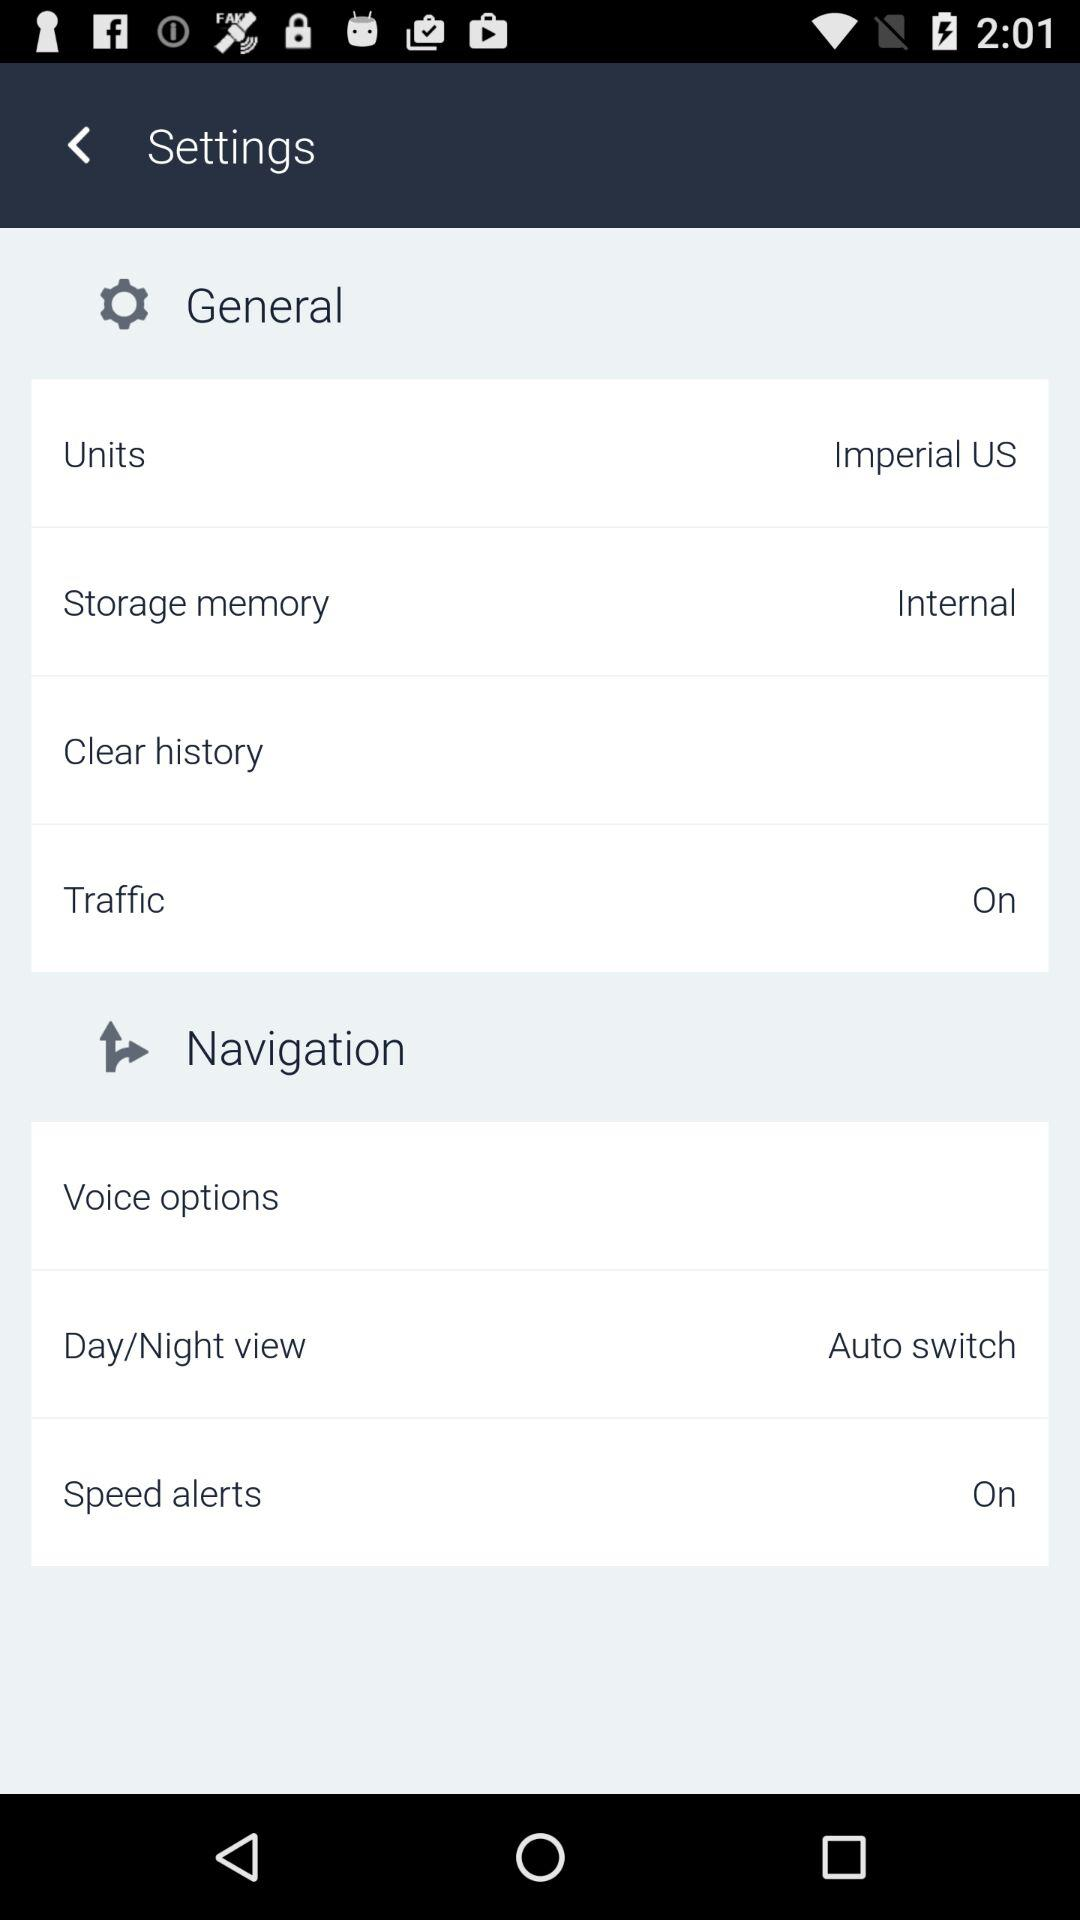What is the type of storage memory? The type of storage memory is internal. 